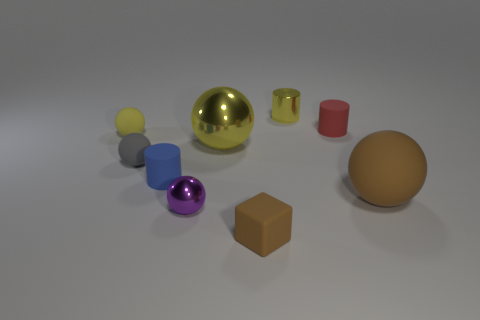Subtract all small spheres. How many spheres are left? 2 Add 1 small cyan balls. How many objects exist? 10 Subtract all red cylinders. How many cylinders are left? 2 Subtract all cylinders. How many objects are left? 6 Subtract 2 cylinders. How many cylinders are left? 1 Subtract all red cubes. Subtract all cyan cylinders. How many cubes are left? 1 Subtract all blue spheres. How many blue cubes are left? 0 Subtract all tiny red cylinders. Subtract all purple metallic spheres. How many objects are left? 7 Add 4 cylinders. How many cylinders are left? 7 Add 6 small gray matte spheres. How many small gray matte spheres exist? 7 